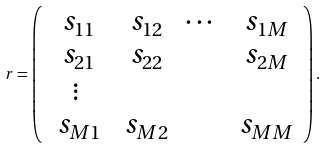Convert formula to latex. <formula><loc_0><loc_0><loc_500><loc_500>\ r = \left ( \begin{array} { c c c c c } \ s _ { 1 1 } & \ s _ { 1 2 } & \cdots & \ s _ { 1 M } \\ \ s _ { 2 1 } & \ s _ { 2 2 } & & \ s _ { 2 M } \\ \vdots & & & \\ \ s _ { M 1 } & \ s _ { M 2 } & & \ s _ { M M } \\ \end{array} \right ) .</formula> 